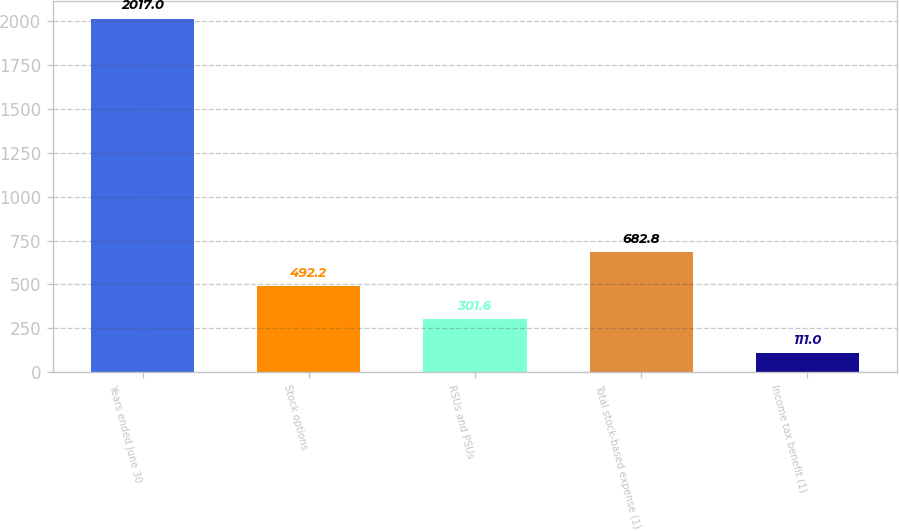Convert chart to OTSL. <chart><loc_0><loc_0><loc_500><loc_500><bar_chart><fcel>Years ended June 30<fcel>Stock options<fcel>RSUs and PSUs<fcel>Total stock-based expense (1)<fcel>Income tax benefit (1)<nl><fcel>2017<fcel>492.2<fcel>301.6<fcel>682.8<fcel>111<nl></chart> 